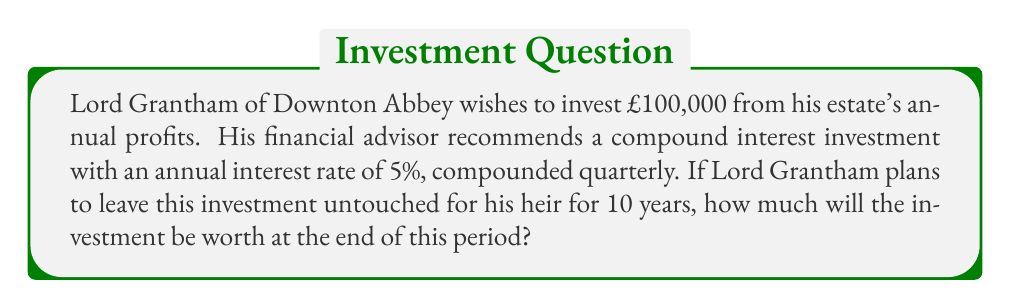Could you help me with this problem? To solve this problem, we'll use the compound interest formula:

$$ A = P(1 + \frac{r}{n})^{nt} $$

Where:
$A$ = Final amount
$P$ = Principal (initial investment)
$r$ = Annual interest rate (as a decimal)
$n$ = Number of times interest is compounded per year
$t$ = Number of years

Given:
$P = £100,000$
$r = 5\% = 0.05$
$n = 4$ (compounded quarterly)
$t = 10$ years

Let's substitute these values into the formula:

$$ A = 100,000(1 + \frac{0.05}{4})^{4 \times 10} $$

$$ A = 100,000(1 + 0.0125)^{40} $$

$$ A = 100,000(1.0125)^{40} $$

Using a calculator or computer to evaluate this expression:

$$ A = 100,000 \times 1.6386 $$

$$ A = 163,860 $$

Therefore, after 10 years, Lord Grantham's investment will be worth £163,860.
Answer: £163,860 